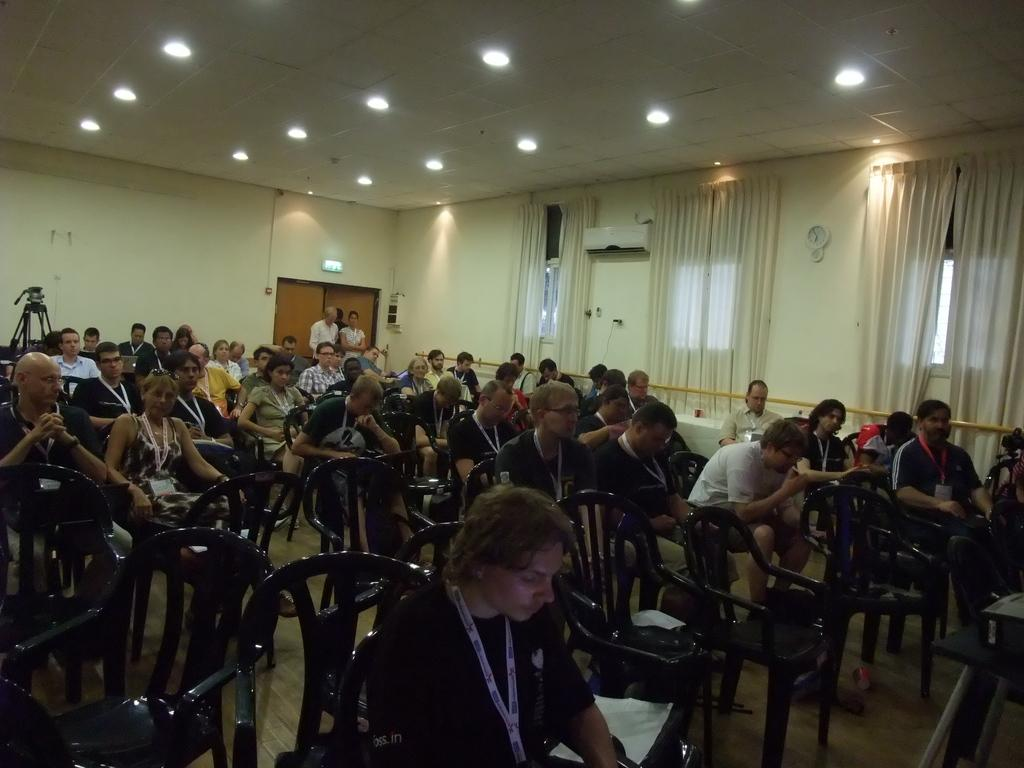What are the people in the image doing? The people in the image are sitting on chairs. What type of window treatment can be seen in the image? There are curtains visible in the image. What is located on the roof in the image? There are lights on the roof in the image. What type of road can be seen in the image? There is no road visible in the image. Can you hear the people talking in the image? The image is a still picture, so we cannot hear any sounds or conversations. 